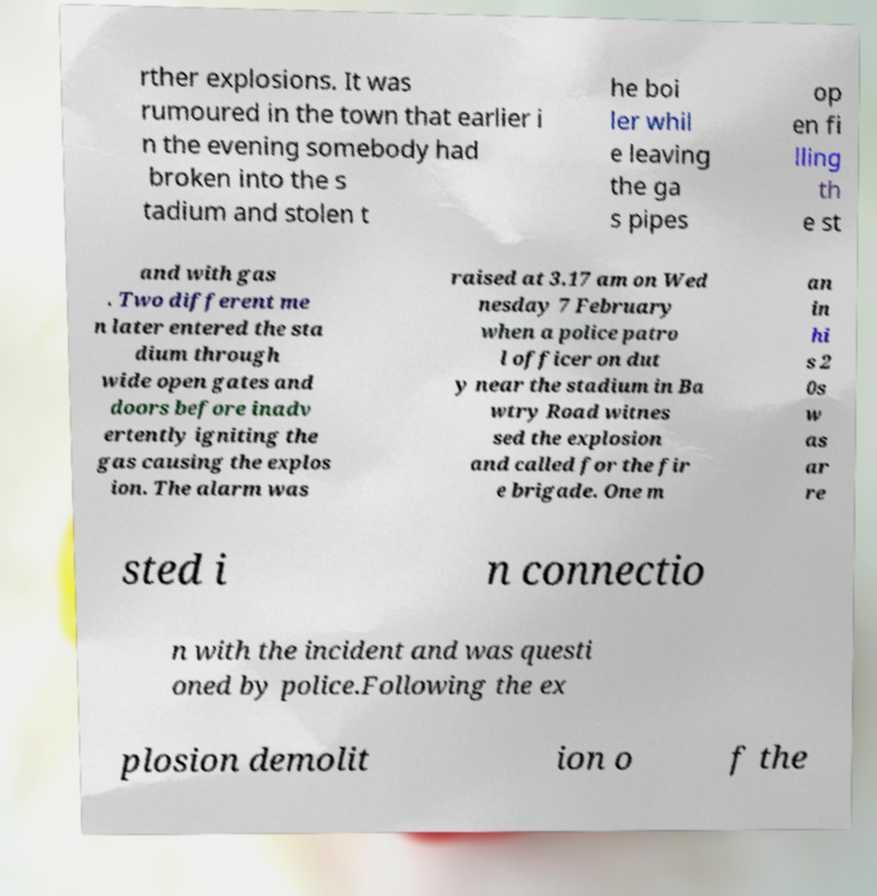Could you assist in decoding the text presented in this image and type it out clearly? rther explosions. It was rumoured in the town that earlier i n the evening somebody had broken into the s tadium and stolen t he boi ler whil e leaving the ga s pipes op en fi lling th e st and with gas . Two different me n later entered the sta dium through wide open gates and doors before inadv ertently igniting the gas causing the explos ion. The alarm was raised at 3.17 am on Wed nesday 7 February when a police patro l officer on dut y near the stadium in Ba wtry Road witnes sed the explosion and called for the fir e brigade. One m an in hi s 2 0s w as ar re sted i n connectio n with the incident and was questi oned by police.Following the ex plosion demolit ion o f the 